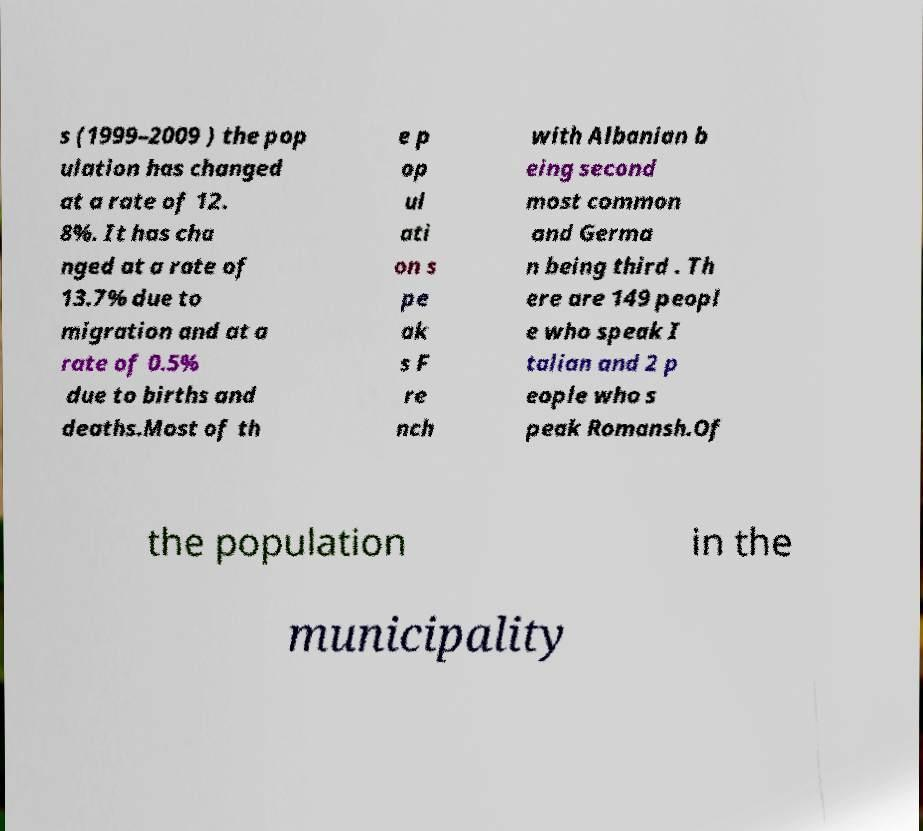Could you extract and type out the text from this image? s (1999–2009 ) the pop ulation has changed at a rate of 12. 8%. It has cha nged at a rate of 13.7% due to migration and at a rate of 0.5% due to births and deaths.Most of th e p op ul ati on s pe ak s F re nch with Albanian b eing second most common and Germa n being third . Th ere are 149 peopl e who speak I talian and 2 p eople who s peak Romansh.Of the population in the municipality 